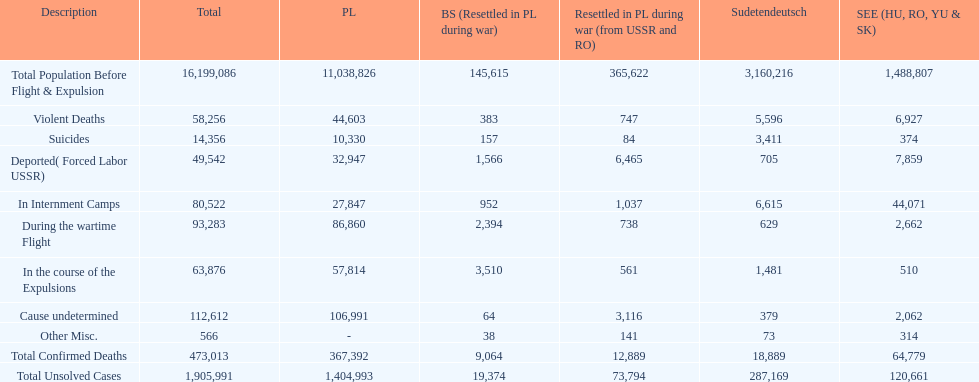What is the total number of violent deaths across all regions? 58,256. 